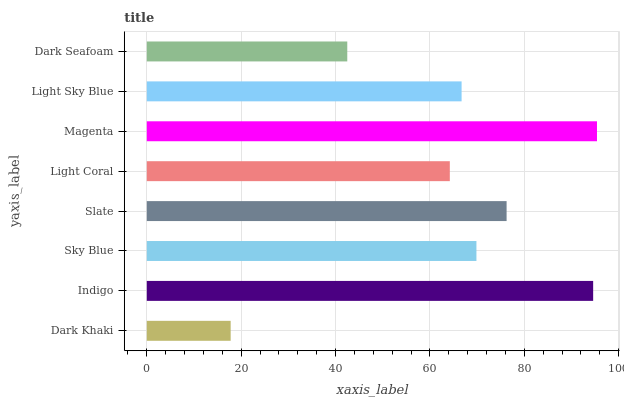Is Dark Khaki the minimum?
Answer yes or no. Yes. Is Magenta the maximum?
Answer yes or no. Yes. Is Indigo the minimum?
Answer yes or no. No. Is Indigo the maximum?
Answer yes or no. No. Is Indigo greater than Dark Khaki?
Answer yes or no. Yes. Is Dark Khaki less than Indigo?
Answer yes or no. Yes. Is Dark Khaki greater than Indigo?
Answer yes or no. No. Is Indigo less than Dark Khaki?
Answer yes or no. No. Is Sky Blue the high median?
Answer yes or no. Yes. Is Light Sky Blue the low median?
Answer yes or no. Yes. Is Indigo the high median?
Answer yes or no. No. Is Dark Seafoam the low median?
Answer yes or no. No. 